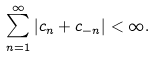Convert formula to latex. <formula><loc_0><loc_0><loc_500><loc_500>\sum _ { n = 1 } ^ { \infty } | c _ { n } + c _ { - n } | < \infty .</formula> 